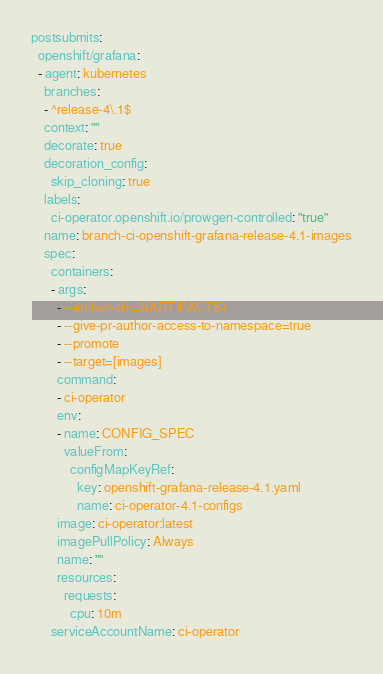Convert code to text. <code><loc_0><loc_0><loc_500><loc_500><_YAML_>postsubmits:
  openshift/grafana:
  - agent: kubernetes
    branches:
    - ^release-4\.1$
    context: ""
    decorate: true
    decoration_config:
      skip_cloning: true
    labels:
      ci-operator.openshift.io/prowgen-controlled: "true"
    name: branch-ci-openshift-grafana-release-4.1-images
    spec:
      containers:
      - args:
        - --artifact-dir=$(ARTIFACTS)
        - --give-pr-author-access-to-namespace=true
        - --promote
        - --target=[images]
        command:
        - ci-operator
        env:
        - name: CONFIG_SPEC
          valueFrom:
            configMapKeyRef:
              key: openshift-grafana-release-4.1.yaml
              name: ci-operator-4.1-configs
        image: ci-operator:latest
        imagePullPolicy: Always
        name: ""
        resources:
          requests:
            cpu: 10m
      serviceAccountName: ci-operator
</code> 